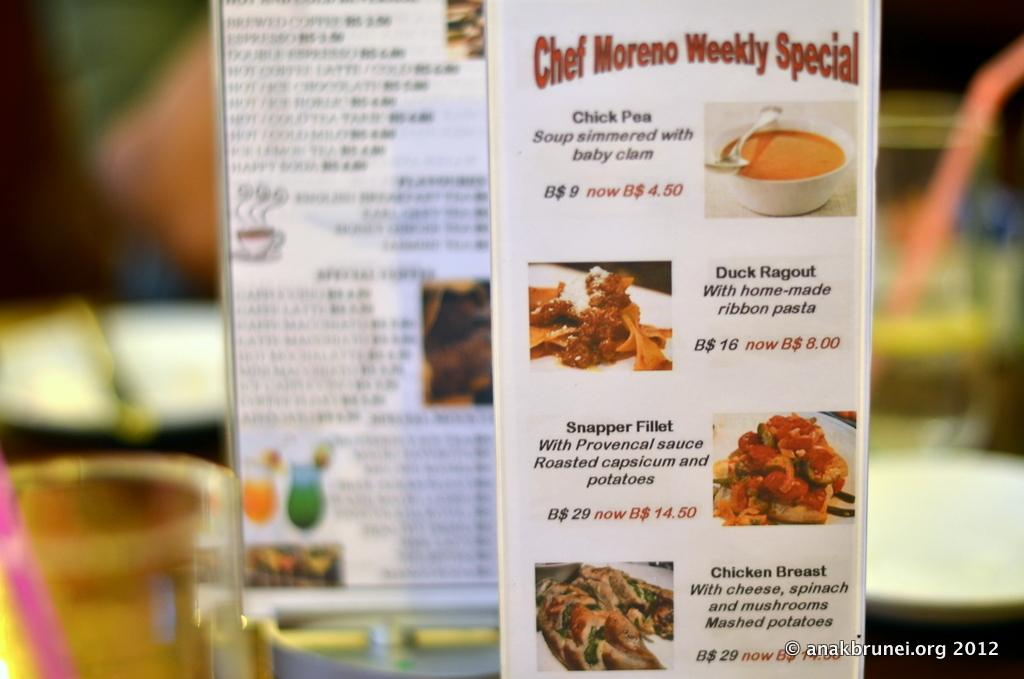Provide a one-sentence caption for the provided image. A printed menu featuring a variety of items including seafood. 